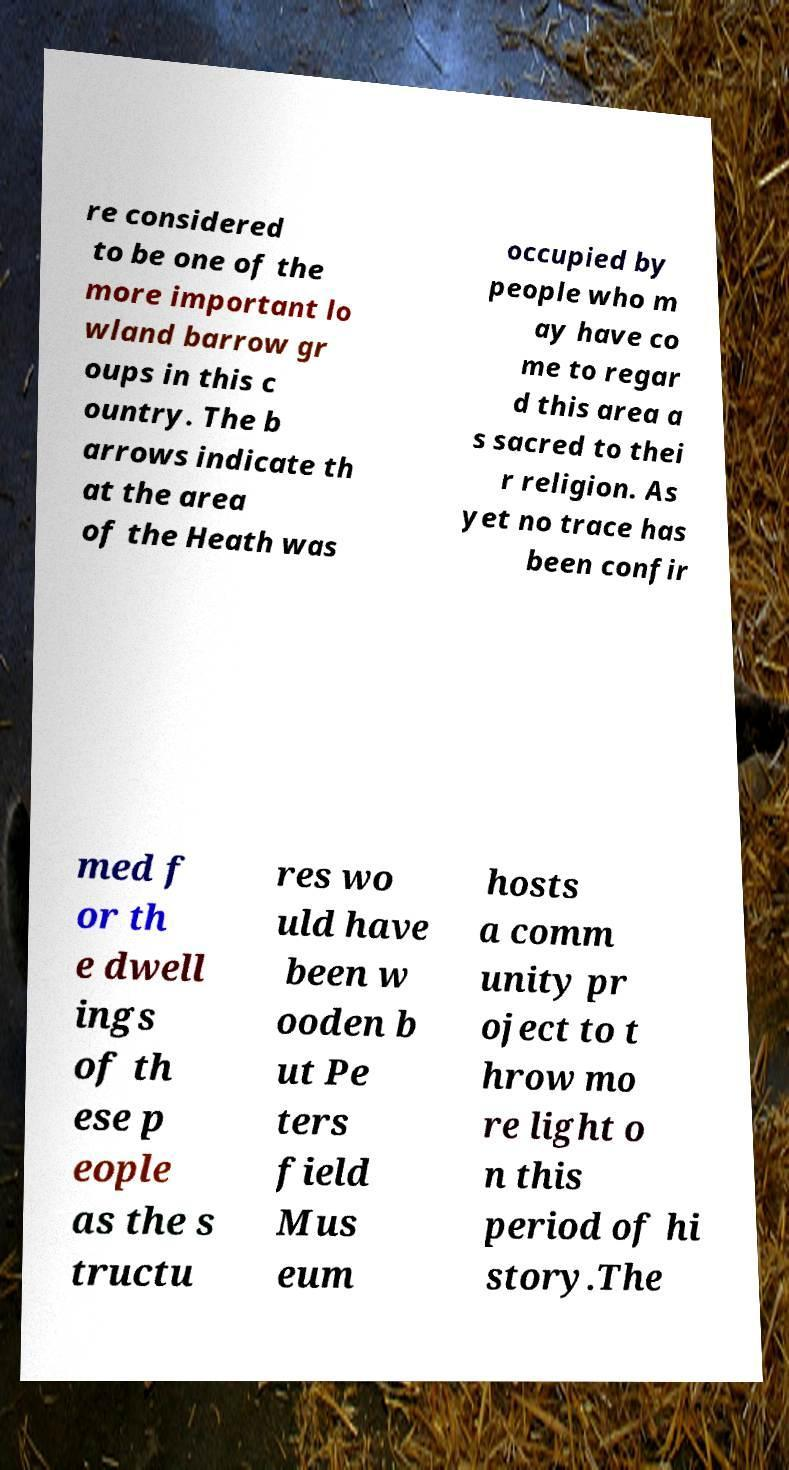I need the written content from this picture converted into text. Can you do that? re considered to be one of the more important lo wland barrow gr oups in this c ountry. The b arrows indicate th at the area of the Heath was occupied by people who m ay have co me to regar d this area a s sacred to thei r religion. As yet no trace has been confir med f or th e dwell ings of th ese p eople as the s tructu res wo uld have been w ooden b ut Pe ters field Mus eum hosts a comm unity pr oject to t hrow mo re light o n this period of hi story.The 